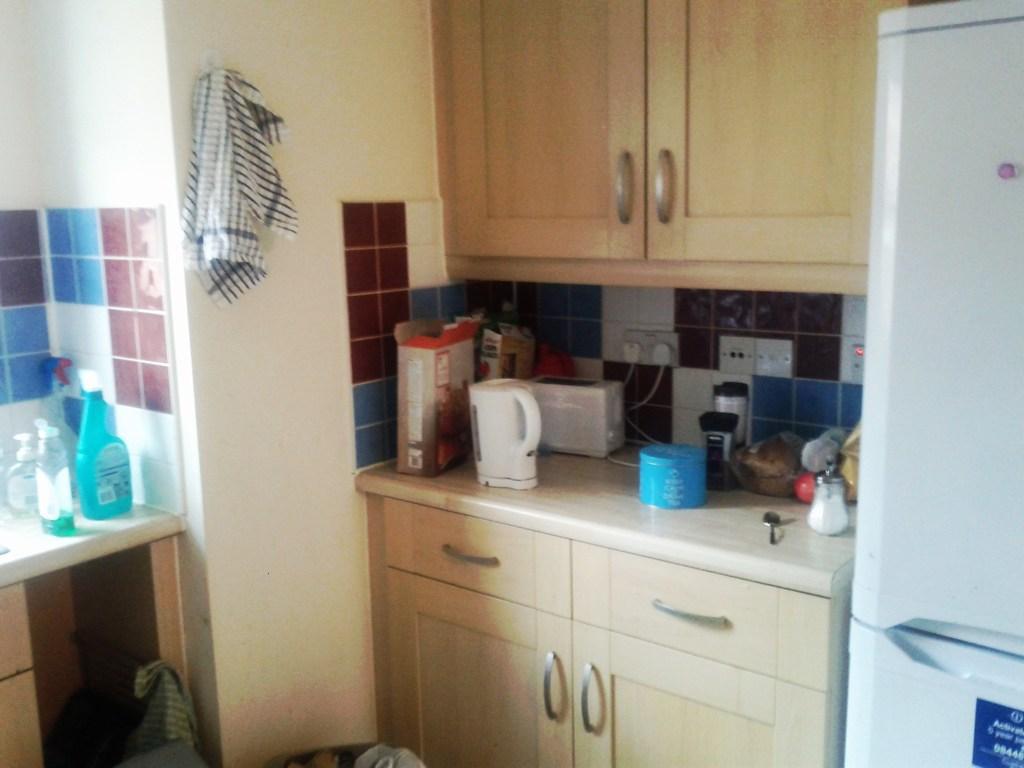Describe this image in one or two sentences. In this image, on the right,we can see a refrigerator. In the center of the image, there is a coffee maker and some jars and containers are placed on the cupboard and in the background, we can see a towel and there are bottles. 